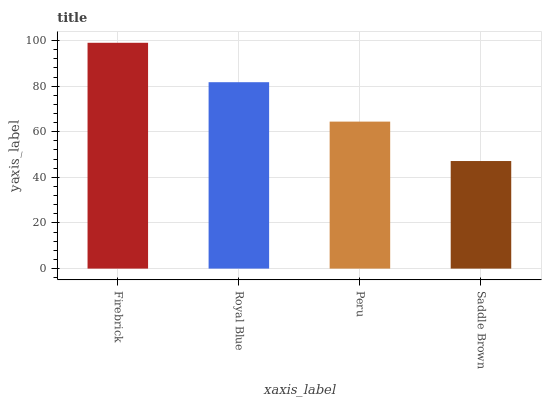Is Saddle Brown the minimum?
Answer yes or no. Yes. Is Firebrick the maximum?
Answer yes or no. Yes. Is Royal Blue the minimum?
Answer yes or no. No. Is Royal Blue the maximum?
Answer yes or no. No. Is Firebrick greater than Royal Blue?
Answer yes or no. Yes. Is Royal Blue less than Firebrick?
Answer yes or no. Yes. Is Royal Blue greater than Firebrick?
Answer yes or no. No. Is Firebrick less than Royal Blue?
Answer yes or no. No. Is Royal Blue the high median?
Answer yes or no. Yes. Is Peru the low median?
Answer yes or no. Yes. Is Firebrick the high median?
Answer yes or no. No. Is Royal Blue the low median?
Answer yes or no. No. 